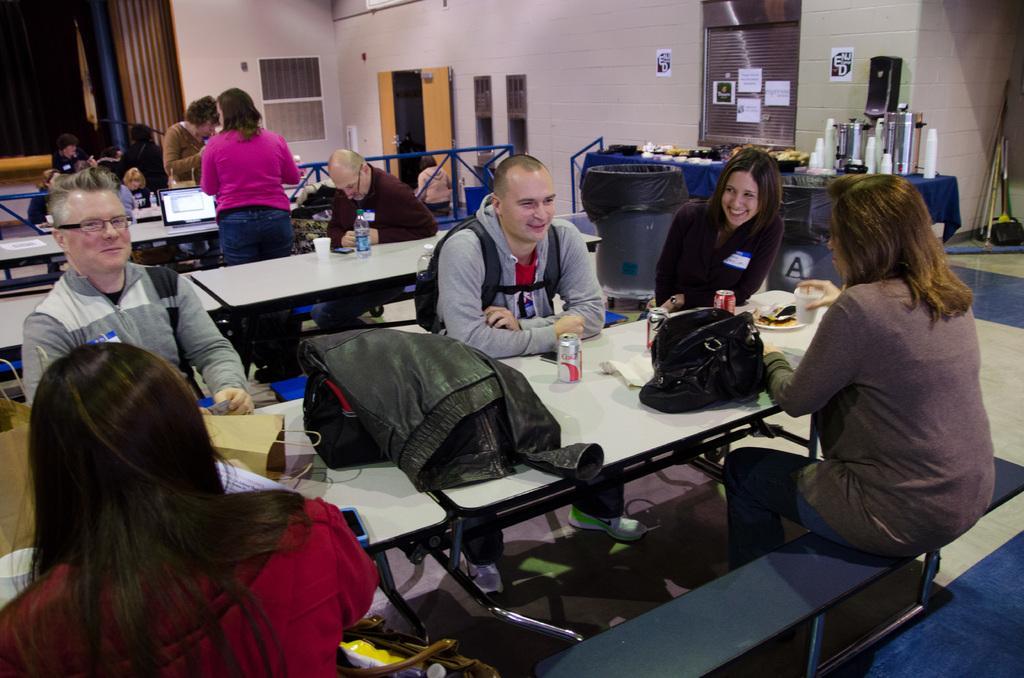How would you summarize this image in a sentence or two? In this picture we can see the tables. On the tables we can see the bags, tins, bottles, cup, laptop, paper, plate which contains food item. Beside the tables we can see some persons are sitting on the benches. In the background of the image we can see the wall, door, boards, papers, rods, sticks, floor. In the middle of the image we can see a table. On the table we can see a cloth, bowls, cups, vessels and some other objects. 